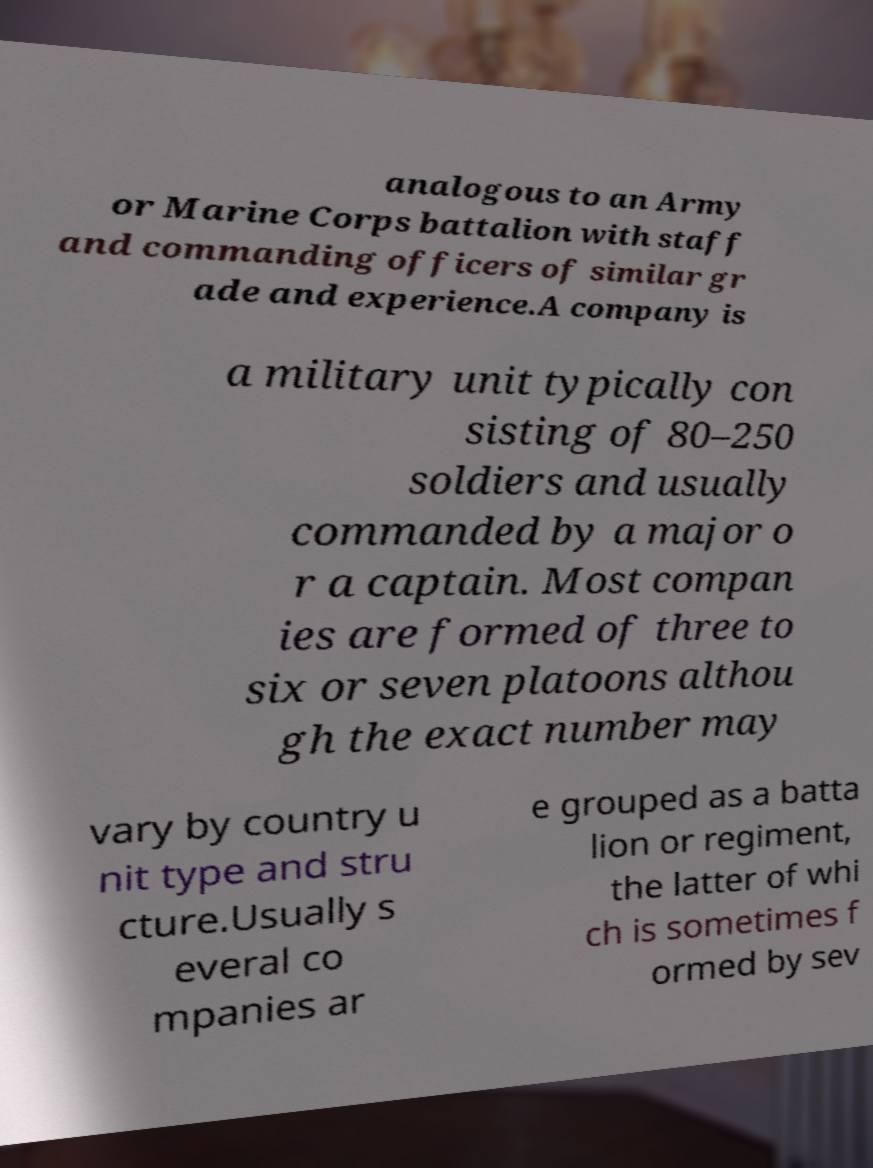Could you assist in decoding the text presented in this image and type it out clearly? analogous to an Army or Marine Corps battalion with staff and commanding officers of similar gr ade and experience.A company is a military unit typically con sisting of 80–250 soldiers and usually commanded by a major o r a captain. Most compan ies are formed of three to six or seven platoons althou gh the exact number may vary by country u nit type and stru cture.Usually s everal co mpanies ar e grouped as a batta lion or regiment, the latter of whi ch is sometimes f ormed by sev 